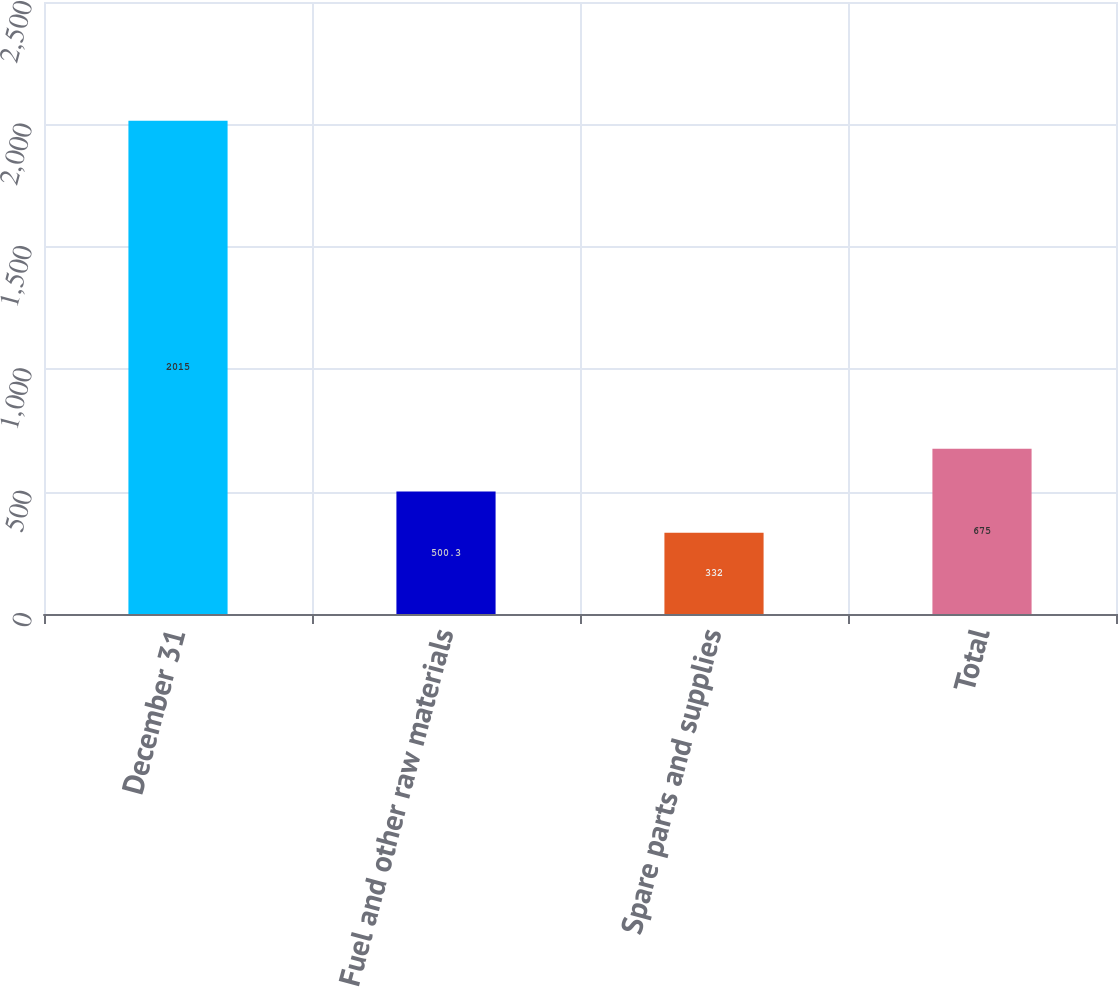Convert chart to OTSL. <chart><loc_0><loc_0><loc_500><loc_500><bar_chart><fcel>December 31<fcel>Fuel and other raw materials<fcel>Spare parts and supplies<fcel>Total<nl><fcel>2015<fcel>500.3<fcel>332<fcel>675<nl></chart> 